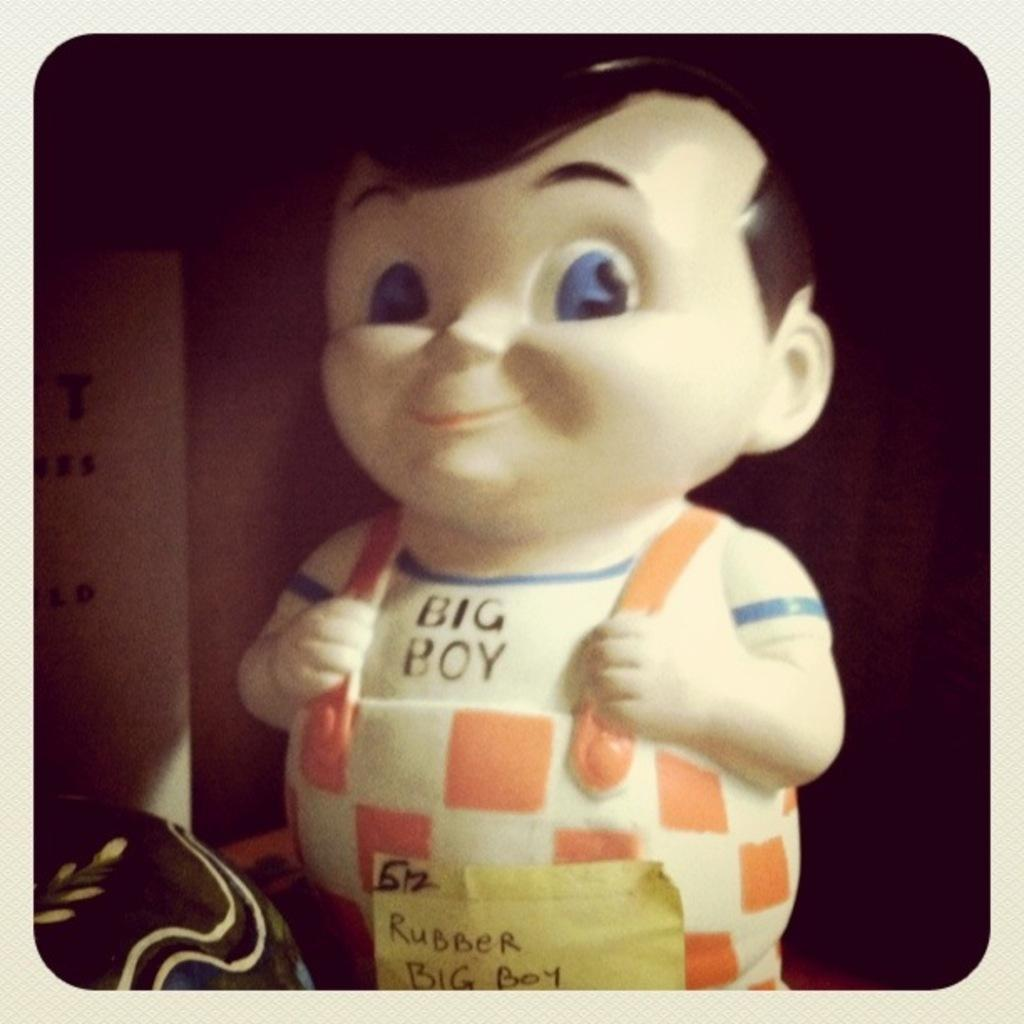What type of toy is present in the image? There is a toy of a boy in the image. Is there any additional information about the toy? Yes, there is a paper attached to the toy. What can be seen in the background of the image? There is a cardboard box in the background of the image. What type of teeth can be seen on the toy in the image? There are no teeth visible on the toy in the image. 